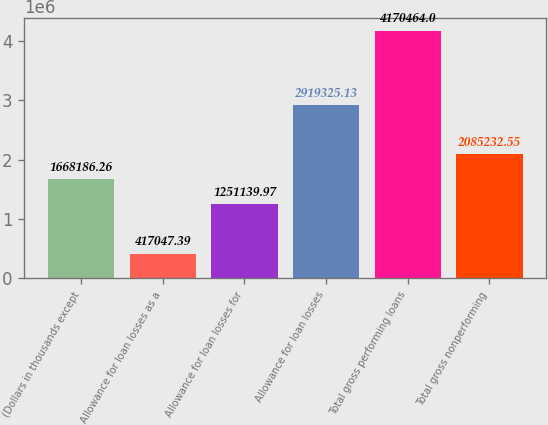Convert chart. <chart><loc_0><loc_0><loc_500><loc_500><bar_chart><fcel>(Dollars in thousands except<fcel>Allowance for loan losses as a<fcel>Allowance for loan losses for<fcel>Allowance for loan losses<fcel>Total gross performing loans<fcel>Total gross nonperforming<nl><fcel>1.66819e+06<fcel>417047<fcel>1.25114e+06<fcel>2.91933e+06<fcel>4.17046e+06<fcel>2.08523e+06<nl></chart> 